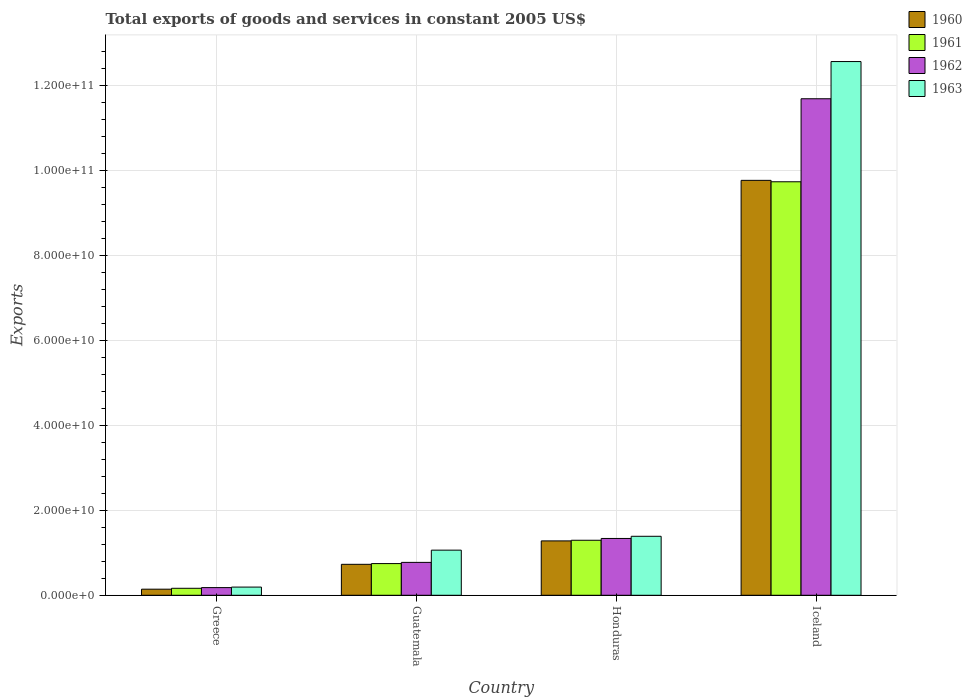How many groups of bars are there?
Offer a terse response. 4. Are the number of bars on each tick of the X-axis equal?
Your response must be concise. Yes. How many bars are there on the 2nd tick from the left?
Ensure brevity in your answer.  4. What is the label of the 2nd group of bars from the left?
Offer a very short reply. Guatemala. In how many cases, is the number of bars for a given country not equal to the number of legend labels?
Ensure brevity in your answer.  0. What is the total exports of goods and services in 1963 in Guatemala?
Ensure brevity in your answer.  1.06e+1. Across all countries, what is the maximum total exports of goods and services in 1963?
Make the answer very short. 1.26e+11. Across all countries, what is the minimum total exports of goods and services in 1962?
Offer a very short reply. 1.81e+09. In which country was the total exports of goods and services in 1960 minimum?
Keep it short and to the point. Greece. What is the total total exports of goods and services in 1960 in the graph?
Give a very brief answer. 1.19e+11. What is the difference between the total exports of goods and services in 1963 in Honduras and that in Iceland?
Your answer should be compact. -1.12e+11. What is the difference between the total exports of goods and services in 1963 in Guatemala and the total exports of goods and services in 1961 in Honduras?
Your answer should be very brief. -2.33e+09. What is the average total exports of goods and services in 1962 per country?
Keep it short and to the point. 3.50e+1. What is the difference between the total exports of goods and services of/in 1961 and total exports of goods and services of/in 1963 in Iceland?
Offer a very short reply. -2.83e+1. In how many countries, is the total exports of goods and services in 1961 greater than 48000000000 US$?
Give a very brief answer. 1. What is the ratio of the total exports of goods and services in 1961 in Guatemala to that in Honduras?
Offer a terse response. 0.58. Is the difference between the total exports of goods and services in 1961 in Greece and Iceland greater than the difference between the total exports of goods and services in 1963 in Greece and Iceland?
Offer a terse response. Yes. What is the difference between the highest and the second highest total exports of goods and services in 1962?
Give a very brief answer. 5.63e+09. What is the difference between the highest and the lowest total exports of goods and services in 1961?
Your response must be concise. 9.57e+1. In how many countries, is the total exports of goods and services in 1962 greater than the average total exports of goods and services in 1962 taken over all countries?
Ensure brevity in your answer.  1. Is the sum of the total exports of goods and services in 1960 in Greece and Guatemala greater than the maximum total exports of goods and services in 1961 across all countries?
Provide a short and direct response. No. Is it the case that in every country, the sum of the total exports of goods and services in 1962 and total exports of goods and services in 1963 is greater than the sum of total exports of goods and services in 1961 and total exports of goods and services in 1960?
Offer a very short reply. No. What does the 4th bar from the left in Greece represents?
Offer a very short reply. 1963. What does the 3rd bar from the right in Guatemala represents?
Provide a succinct answer. 1961. How many bars are there?
Ensure brevity in your answer.  16. How many countries are there in the graph?
Your response must be concise. 4. What is the difference between two consecutive major ticks on the Y-axis?
Provide a short and direct response. 2.00e+1. Are the values on the major ticks of Y-axis written in scientific E-notation?
Provide a short and direct response. Yes. Does the graph contain grids?
Give a very brief answer. Yes. How are the legend labels stacked?
Your answer should be compact. Vertical. What is the title of the graph?
Offer a terse response. Total exports of goods and services in constant 2005 US$. Does "1962" appear as one of the legend labels in the graph?
Your answer should be compact. Yes. What is the label or title of the X-axis?
Ensure brevity in your answer.  Country. What is the label or title of the Y-axis?
Your answer should be very brief. Exports. What is the Exports of 1960 in Greece?
Provide a short and direct response. 1.43e+09. What is the Exports of 1961 in Greece?
Offer a very short reply. 1.64e+09. What is the Exports in 1962 in Greece?
Your answer should be very brief. 1.81e+09. What is the Exports of 1963 in Greece?
Keep it short and to the point. 1.93e+09. What is the Exports of 1960 in Guatemala?
Offer a terse response. 7.29e+09. What is the Exports in 1961 in Guatemala?
Ensure brevity in your answer.  7.46e+09. What is the Exports of 1962 in Guatemala?
Make the answer very short. 7.75e+09. What is the Exports of 1963 in Guatemala?
Your answer should be very brief. 1.06e+1. What is the Exports of 1960 in Honduras?
Provide a succinct answer. 1.28e+1. What is the Exports of 1961 in Honduras?
Provide a short and direct response. 1.30e+1. What is the Exports in 1962 in Honduras?
Provide a short and direct response. 1.34e+1. What is the Exports in 1963 in Honduras?
Provide a short and direct response. 1.39e+1. What is the Exports of 1960 in Iceland?
Your response must be concise. 9.77e+1. What is the Exports of 1961 in Iceland?
Your answer should be compact. 9.74e+1. What is the Exports in 1962 in Iceland?
Provide a succinct answer. 1.17e+11. What is the Exports of 1963 in Iceland?
Give a very brief answer. 1.26e+11. Across all countries, what is the maximum Exports in 1960?
Your answer should be compact. 9.77e+1. Across all countries, what is the maximum Exports of 1961?
Offer a terse response. 9.74e+1. Across all countries, what is the maximum Exports of 1962?
Provide a succinct answer. 1.17e+11. Across all countries, what is the maximum Exports in 1963?
Your answer should be compact. 1.26e+11. Across all countries, what is the minimum Exports in 1960?
Provide a succinct answer. 1.43e+09. Across all countries, what is the minimum Exports of 1961?
Make the answer very short. 1.64e+09. Across all countries, what is the minimum Exports of 1962?
Ensure brevity in your answer.  1.81e+09. Across all countries, what is the minimum Exports of 1963?
Provide a succinct answer. 1.93e+09. What is the total Exports in 1960 in the graph?
Provide a short and direct response. 1.19e+11. What is the total Exports in 1961 in the graph?
Offer a terse response. 1.19e+11. What is the total Exports of 1962 in the graph?
Ensure brevity in your answer.  1.40e+11. What is the total Exports of 1963 in the graph?
Make the answer very short. 1.52e+11. What is the difference between the Exports in 1960 in Greece and that in Guatemala?
Your answer should be very brief. -5.85e+09. What is the difference between the Exports of 1961 in Greece and that in Guatemala?
Your answer should be compact. -5.82e+09. What is the difference between the Exports in 1962 in Greece and that in Guatemala?
Provide a succinct answer. -5.94e+09. What is the difference between the Exports in 1963 in Greece and that in Guatemala?
Your response must be concise. -8.70e+09. What is the difference between the Exports of 1960 in Greece and that in Honduras?
Ensure brevity in your answer.  -1.14e+1. What is the difference between the Exports of 1961 in Greece and that in Honduras?
Offer a very short reply. -1.13e+1. What is the difference between the Exports in 1962 in Greece and that in Honduras?
Offer a very short reply. -1.16e+1. What is the difference between the Exports in 1963 in Greece and that in Honduras?
Give a very brief answer. -1.20e+1. What is the difference between the Exports of 1960 in Greece and that in Iceland?
Keep it short and to the point. -9.63e+1. What is the difference between the Exports of 1961 in Greece and that in Iceland?
Provide a succinct answer. -9.57e+1. What is the difference between the Exports in 1962 in Greece and that in Iceland?
Your response must be concise. -1.15e+11. What is the difference between the Exports of 1963 in Greece and that in Iceland?
Offer a very short reply. -1.24e+11. What is the difference between the Exports in 1960 in Guatemala and that in Honduras?
Offer a terse response. -5.51e+09. What is the difference between the Exports of 1961 in Guatemala and that in Honduras?
Offer a very short reply. -5.49e+09. What is the difference between the Exports in 1962 in Guatemala and that in Honduras?
Ensure brevity in your answer.  -5.63e+09. What is the difference between the Exports of 1963 in Guatemala and that in Honduras?
Your answer should be very brief. -3.26e+09. What is the difference between the Exports in 1960 in Guatemala and that in Iceland?
Give a very brief answer. -9.04e+1. What is the difference between the Exports in 1961 in Guatemala and that in Iceland?
Your response must be concise. -8.99e+1. What is the difference between the Exports in 1962 in Guatemala and that in Iceland?
Offer a very short reply. -1.09e+11. What is the difference between the Exports in 1963 in Guatemala and that in Iceland?
Keep it short and to the point. -1.15e+11. What is the difference between the Exports in 1960 in Honduras and that in Iceland?
Your answer should be compact. -8.49e+1. What is the difference between the Exports in 1961 in Honduras and that in Iceland?
Ensure brevity in your answer.  -8.44e+1. What is the difference between the Exports of 1962 in Honduras and that in Iceland?
Your answer should be very brief. -1.04e+11. What is the difference between the Exports in 1963 in Honduras and that in Iceland?
Offer a very short reply. -1.12e+11. What is the difference between the Exports in 1960 in Greece and the Exports in 1961 in Guatemala?
Give a very brief answer. -6.02e+09. What is the difference between the Exports of 1960 in Greece and the Exports of 1962 in Guatemala?
Offer a terse response. -6.31e+09. What is the difference between the Exports of 1960 in Greece and the Exports of 1963 in Guatemala?
Your response must be concise. -9.19e+09. What is the difference between the Exports in 1961 in Greece and the Exports in 1962 in Guatemala?
Offer a terse response. -6.10e+09. What is the difference between the Exports in 1961 in Greece and the Exports in 1963 in Guatemala?
Ensure brevity in your answer.  -8.98e+09. What is the difference between the Exports in 1962 in Greece and the Exports in 1963 in Guatemala?
Provide a succinct answer. -8.82e+09. What is the difference between the Exports of 1960 in Greece and the Exports of 1961 in Honduras?
Your answer should be very brief. -1.15e+1. What is the difference between the Exports of 1960 in Greece and the Exports of 1962 in Honduras?
Your response must be concise. -1.19e+1. What is the difference between the Exports in 1960 in Greece and the Exports in 1963 in Honduras?
Offer a very short reply. -1.25e+1. What is the difference between the Exports of 1961 in Greece and the Exports of 1962 in Honduras?
Your response must be concise. -1.17e+1. What is the difference between the Exports in 1961 in Greece and the Exports in 1963 in Honduras?
Offer a terse response. -1.22e+1. What is the difference between the Exports in 1962 in Greece and the Exports in 1963 in Honduras?
Provide a short and direct response. -1.21e+1. What is the difference between the Exports of 1960 in Greece and the Exports of 1961 in Iceland?
Offer a terse response. -9.59e+1. What is the difference between the Exports of 1960 in Greece and the Exports of 1962 in Iceland?
Your answer should be very brief. -1.15e+11. What is the difference between the Exports in 1960 in Greece and the Exports in 1963 in Iceland?
Give a very brief answer. -1.24e+11. What is the difference between the Exports in 1961 in Greece and the Exports in 1962 in Iceland?
Your answer should be compact. -1.15e+11. What is the difference between the Exports in 1961 in Greece and the Exports in 1963 in Iceland?
Make the answer very short. -1.24e+11. What is the difference between the Exports of 1962 in Greece and the Exports of 1963 in Iceland?
Offer a very short reply. -1.24e+11. What is the difference between the Exports in 1960 in Guatemala and the Exports in 1961 in Honduras?
Offer a terse response. -5.66e+09. What is the difference between the Exports in 1960 in Guatemala and the Exports in 1962 in Honduras?
Your response must be concise. -6.09e+09. What is the difference between the Exports in 1960 in Guatemala and the Exports in 1963 in Honduras?
Give a very brief answer. -6.60e+09. What is the difference between the Exports of 1961 in Guatemala and the Exports of 1962 in Honduras?
Keep it short and to the point. -5.92e+09. What is the difference between the Exports of 1961 in Guatemala and the Exports of 1963 in Honduras?
Keep it short and to the point. -6.43e+09. What is the difference between the Exports in 1962 in Guatemala and the Exports in 1963 in Honduras?
Provide a succinct answer. -6.14e+09. What is the difference between the Exports in 1960 in Guatemala and the Exports in 1961 in Iceland?
Your answer should be compact. -9.01e+1. What is the difference between the Exports of 1960 in Guatemala and the Exports of 1962 in Iceland?
Your response must be concise. -1.10e+11. What is the difference between the Exports in 1960 in Guatemala and the Exports in 1963 in Iceland?
Your answer should be compact. -1.18e+11. What is the difference between the Exports in 1961 in Guatemala and the Exports in 1962 in Iceland?
Make the answer very short. -1.09e+11. What is the difference between the Exports in 1961 in Guatemala and the Exports in 1963 in Iceland?
Your answer should be compact. -1.18e+11. What is the difference between the Exports of 1962 in Guatemala and the Exports of 1963 in Iceland?
Keep it short and to the point. -1.18e+11. What is the difference between the Exports of 1960 in Honduras and the Exports of 1961 in Iceland?
Offer a very short reply. -8.46e+1. What is the difference between the Exports of 1960 in Honduras and the Exports of 1962 in Iceland?
Provide a short and direct response. -1.04e+11. What is the difference between the Exports in 1960 in Honduras and the Exports in 1963 in Iceland?
Your response must be concise. -1.13e+11. What is the difference between the Exports in 1961 in Honduras and the Exports in 1962 in Iceland?
Your response must be concise. -1.04e+11. What is the difference between the Exports in 1961 in Honduras and the Exports in 1963 in Iceland?
Your response must be concise. -1.13e+11. What is the difference between the Exports in 1962 in Honduras and the Exports in 1963 in Iceland?
Keep it short and to the point. -1.12e+11. What is the average Exports of 1960 per country?
Make the answer very short. 2.98e+1. What is the average Exports of 1961 per country?
Offer a very short reply. 2.99e+1. What is the average Exports of 1962 per country?
Offer a terse response. 3.50e+1. What is the average Exports in 1963 per country?
Provide a succinct answer. 3.80e+1. What is the difference between the Exports of 1960 and Exports of 1961 in Greece?
Offer a terse response. -2.08e+08. What is the difference between the Exports in 1960 and Exports in 1962 in Greece?
Offer a very short reply. -3.72e+08. What is the difference between the Exports of 1960 and Exports of 1963 in Greece?
Offer a terse response. -4.92e+08. What is the difference between the Exports of 1961 and Exports of 1962 in Greece?
Offer a terse response. -1.64e+08. What is the difference between the Exports in 1961 and Exports in 1963 in Greece?
Ensure brevity in your answer.  -2.84e+08. What is the difference between the Exports of 1962 and Exports of 1963 in Greece?
Your response must be concise. -1.20e+08. What is the difference between the Exports of 1960 and Exports of 1961 in Guatemala?
Your response must be concise. -1.71e+08. What is the difference between the Exports in 1960 and Exports in 1962 in Guatemala?
Offer a very short reply. -4.57e+08. What is the difference between the Exports in 1960 and Exports in 1963 in Guatemala?
Offer a terse response. -3.33e+09. What is the difference between the Exports of 1961 and Exports of 1962 in Guatemala?
Provide a short and direct response. -2.86e+08. What is the difference between the Exports of 1961 and Exports of 1963 in Guatemala?
Your response must be concise. -3.16e+09. What is the difference between the Exports of 1962 and Exports of 1963 in Guatemala?
Ensure brevity in your answer.  -2.88e+09. What is the difference between the Exports of 1960 and Exports of 1961 in Honduras?
Give a very brief answer. -1.52e+08. What is the difference between the Exports in 1960 and Exports in 1962 in Honduras?
Provide a succinct answer. -5.74e+08. What is the difference between the Exports in 1960 and Exports in 1963 in Honduras?
Make the answer very short. -1.09e+09. What is the difference between the Exports in 1961 and Exports in 1962 in Honduras?
Keep it short and to the point. -4.22e+08. What is the difference between the Exports of 1961 and Exports of 1963 in Honduras?
Provide a succinct answer. -9.34e+08. What is the difference between the Exports in 1962 and Exports in 1963 in Honduras?
Provide a succinct answer. -5.12e+08. What is the difference between the Exports of 1960 and Exports of 1961 in Iceland?
Your response must be concise. 3.34e+08. What is the difference between the Exports in 1960 and Exports in 1962 in Iceland?
Offer a terse response. -1.92e+1. What is the difference between the Exports in 1960 and Exports in 1963 in Iceland?
Your response must be concise. -2.80e+1. What is the difference between the Exports of 1961 and Exports of 1962 in Iceland?
Ensure brevity in your answer.  -1.95e+1. What is the difference between the Exports of 1961 and Exports of 1963 in Iceland?
Offer a terse response. -2.83e+1. What is the difference between the Exports in 1962 and Exports in 1963 in Iceland?
Your answer should be very brief. -8.76e+09. What is the ratio of the Exports of 1960 in Greece to that in Guatemala?
Keep it short and to the point. 0.2. What is the ratio of the Exports of 1961 in Greece to that in Guatemala?
Provide a short and direct response. 0.22. What is the ratio of the Exports in 1962 in Greece to that in Guatemala?
Your response must be concise. 0.23. What is the ratio of the Exports in 1963 in Greece to that in Guatemala?
Keep it short and to the point. 0.18. What is the ratio of the Exports in 1960 in Greece to that in Honduras?
Keep it short and to the point. 0.11. What is the ratio of the Exports of 1961 in Greece to that in Honduras?
Give a very brief answer. 0.13. What is the ratio of the Exports in 1962 in Greece to that in Honduras?
Offer a terse response. 0.14. What is the ratio of the Exports in 1963 in Greece to that in Honduras?
Your answer should be compact. 0.14. What is the ratio of the Exports of 1960 in Greece to that in Iceland?
Provide a succinct answer. 0.01. What is the ratio of the Exports of 1961 in Greece to that in Iceland?
Provide a short and direct response. 0.02. What is the ratio of the Exports in 1962 in Greece to that in Iceland?
Ensure brevity in your answer.  0.02. What is the ratio of the Exports of 1963 in Greece to that in Iceland?
Make the answer very short. 0.02. What is the ratio of the Exports in 1960 in Guatemala to that in Honduras?
Ensure brevity in your answer.  0.57. What is the ratio of the Exports in 1961 in Guatemala to that in Honduras?
Your answer should be compact. 0.58. What is the ratio of the Exports of 1962 in Guatemala to that in Honduras?
Your answer should be compact. 0.58. What is the ratio of the Exports of 1963 in Guatemala to that in Honduras?
Provide a short and direct response. 0.76. What is the ratio of the Exports of 1960 in Guatemala to that in Iceland?
Offer a terse response. 0.07. What is the ratio of the Exports of 1961 in Guatemala to that in Iceland?
Provide a short and direct response. 0.08. What is the ratio of the Exports of 1962 in Guatemala to that in Iceland?
Offer a terse response. 0.07. What is the ratio of the Exports of 1963 in Guatemala to that in Iceland?
Provide a short and direct response. 0.08. What is the ratio of the Exports in 1960 in Honduras to that in Iceland?
Provide a short and direct response. 0.13. What is the ratio of the Exports in 1961 in Honduras to that in Iceland?
Give a very brief answer. 0.13. What is the ratio of the Exports of 1962 in Honduras to that in Iceland?
Provide a succinct answer. 0.11. What is the ratio of the Exports in 1963 in Honduras to that in Iceland?
Offer a terse response. 0.11. What is the difference between the highest and the second highest Exports of 1960?
Your response must be concise. 8.49e+1. What is the difference between the highest and the second highest Exports in 1961?
Keep it short and to the point. 8.44e+1. What is the difference between the highest and the second highest Exports of 1962?
Your response must be concise. 1.04e+11. What is the difference between the highest and the second highest Exports in 1963?
Provide a short and direct response. 1.12e+11. What is the difference between the highest and the lowest Exports in 1960?
Your response must be concise. 9.63e+1. What is the difference between the highest and the lowest Exports of 1961?
Offer a terse response. 9.57e+1. What is the difference between the highest and the lowest Exports in 1962?
Make the answer very short. 1.15e+11. What is the difference between the highest and the lowest Exports of 1963?
Ensure brevity in your answer.  1.24e+11. 